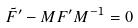Convert formula to latex. <formula><loc_0><loc_0><loc_500><loc_500>\tilde { F } ^ { \prime } - M F ^ { \prime } M ^ { - 1 } = 0</formula> 